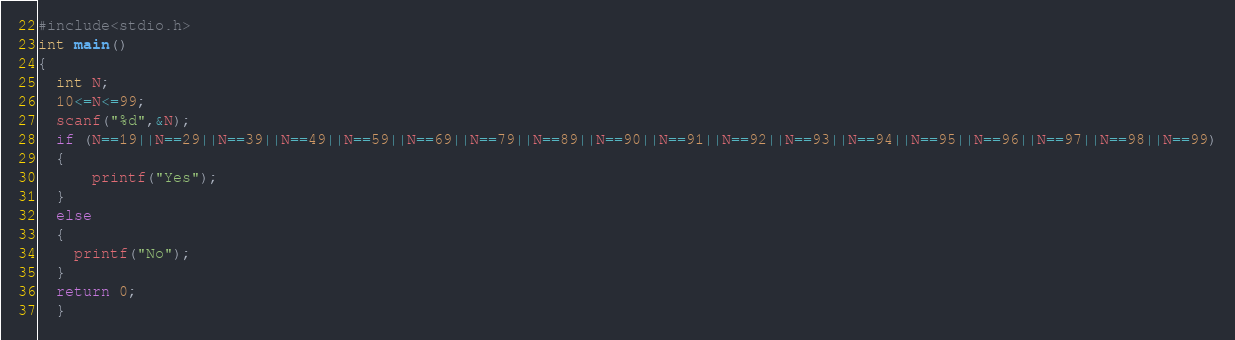Convert code to text. <code><loc_0><loc_0><loc_500><loc_500><_C_>#include<stdio.h>
int main()
{
  int N;
  10<=N<=99;
  scanf("%d",&N);
  if (N==19||N==29||N==39||N==49||N==59||N==69||N==79||N==89||N==90||N==91||N==92||N==93||N==94||N==95||N==96||N==97||N==98||N==99)
  {
      printf("Yes");
  }
  else
  {
    printf("No");
  }
  return 0;
  }
</code> 